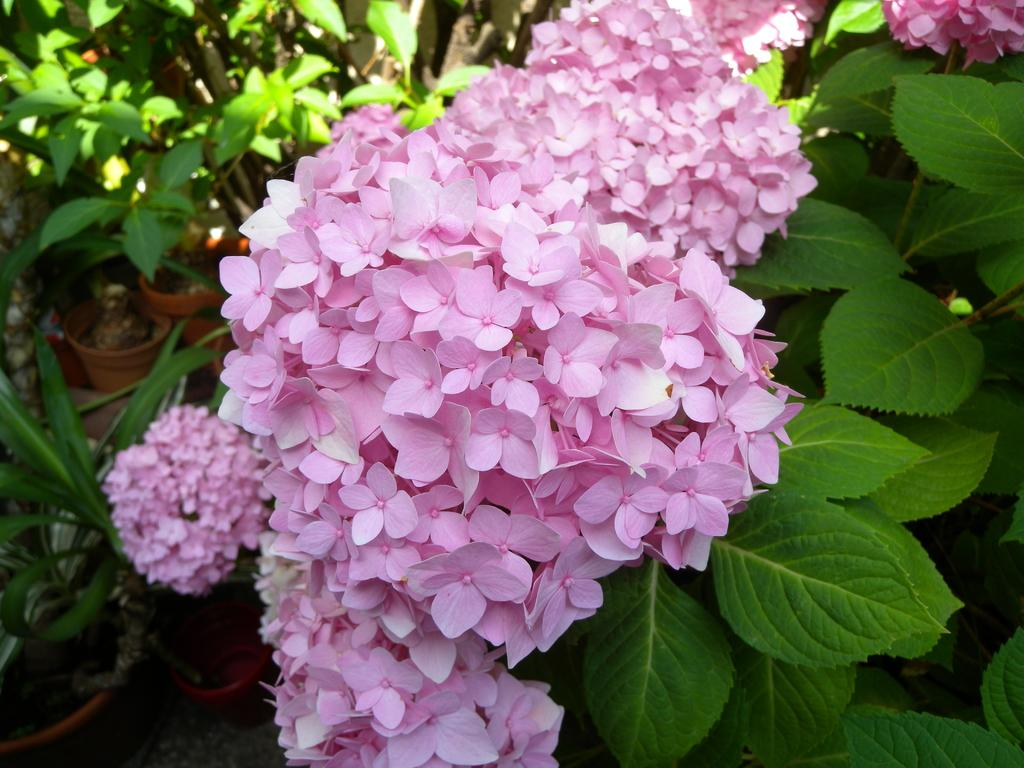What type of flora is present in the image? There are lots of flowers in the image. What color are the flowers? The flowers are pink in color. What can be seen in the background of the image? There are plants and pots in the background of the image. What type of rail can be seen in the image? There is no rail present in the image; it features lots of pink flowers and background elements of plants and pots. 